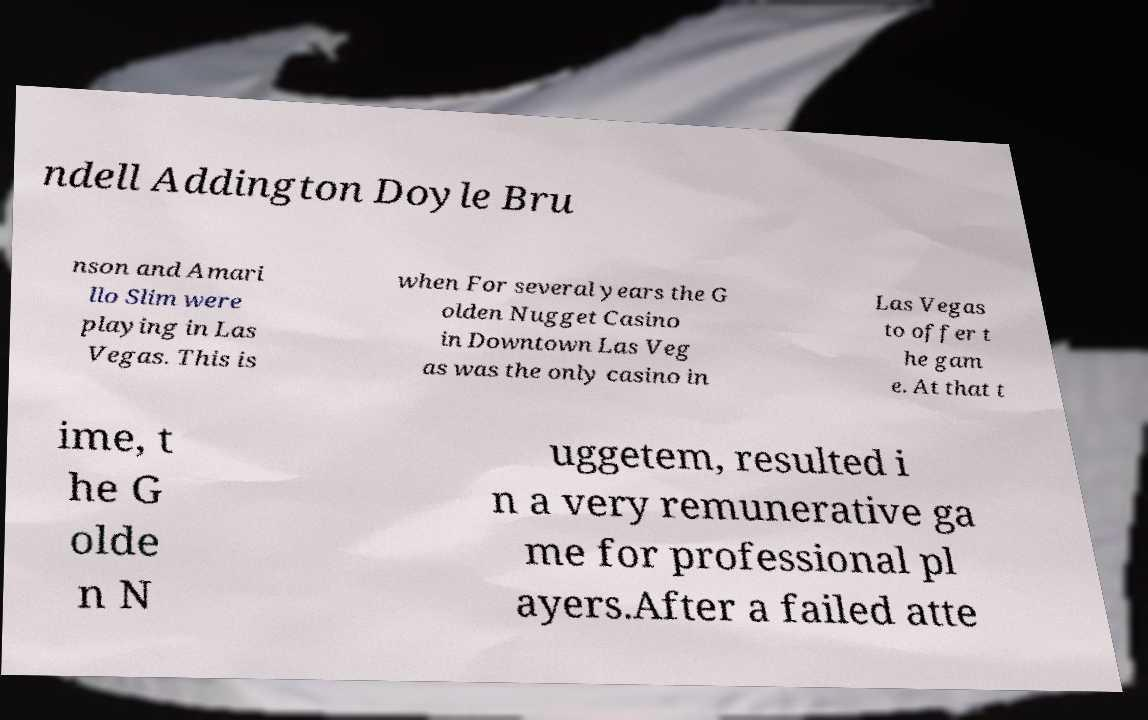Can you accurately transcribe the text from the provided image for me? ndell Addington Doyle Bru nson and Amari llo Slim were playing in Las Vegas. This is when For several years the G olden Nugget Casino in Downtown Las Veg as was the only casino in Las Vegas to offer t he gam e. At that t ime, t he G olde n N uggetem, resulted i n a very remunerative ga me for professional pl ayers.After a failed atte 